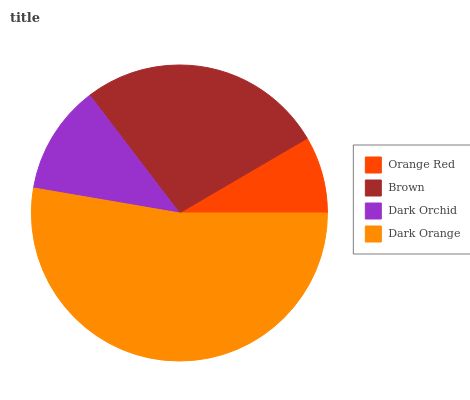Is Orange Red the minimum?
Answer yes or no. Yes. Is Dark Orange the maximum?
Answer yes or no. Yes. Is Brown the minimum?
Answer yes or no. No. Is Brown the maximum?
Answer yes or no. No. Is Brown greater than Orange Red?
Answer yes or no. Yes. Is Orange Red less than Brown?
Answer yes or no. Yes. Is Orange Red greater than Brown?
Answer yes or no. No. Is Brown less than Orange Red?
Answer yes or no. No. Is Brown the high median?
Answer yes or no. Yes. Is Dark Orchid the low median?
Answer yes or no. Yes. Is Dark Orange the high median?
Answer yes or no. No. Is Brown the low median?
Answer yes or no. No. 